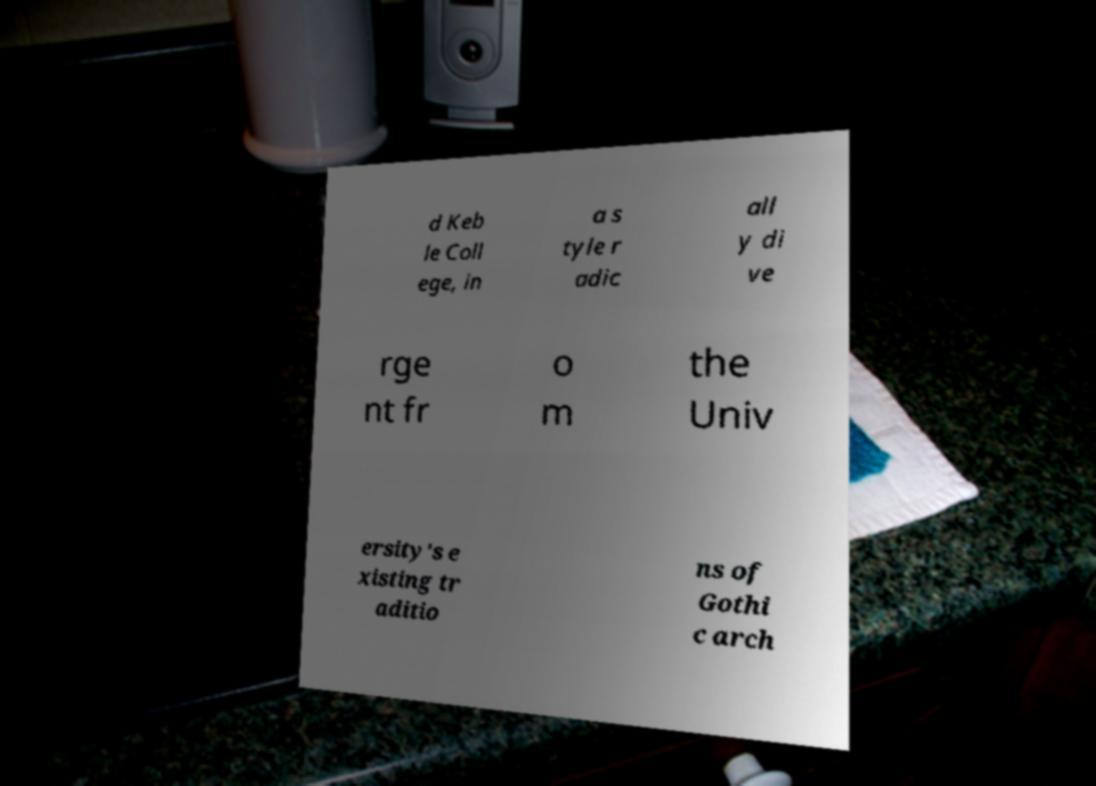Could you assist in decoding the text presented in this image and type it out clearly? d Keb le Coll ege, in a s tyle r adic all y di ve rge nt fr o m the Univ ersity's e xisting tr aditio ns of Gothi c arch 